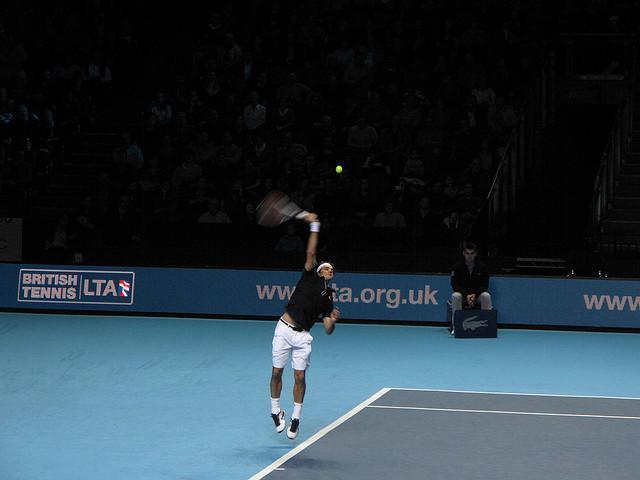How many balls are on the ground?
Give a very brief answer. 0. How many people are in the picture?
Give a very brief answer. 3. How many sets of train tracks are there?
Give a very brief answer. 0. 